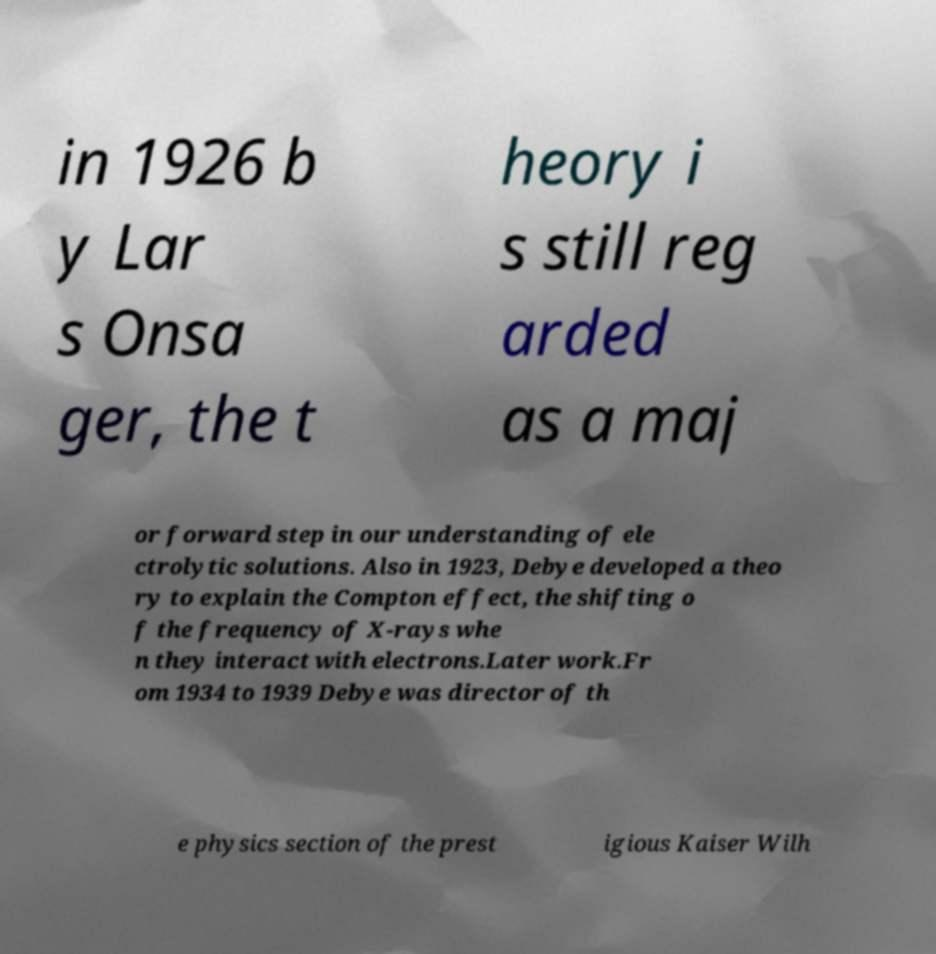Please read and relay the text visible in this image. What does it say? in 1926 b y Lar s Onsa ger, the t heory i s still reg arded as a maj or forward step in our understanding of ele ctrolytic solutions. Also in 1923, Debye developed a theo ry to explain the Compton effect, the shifting o f the frequency of X-rays whe n they interact with electrons.Later work.Fr om 1934 to 1939 Debye was director of th e physics section of the prest igious Kaiser Wilh 